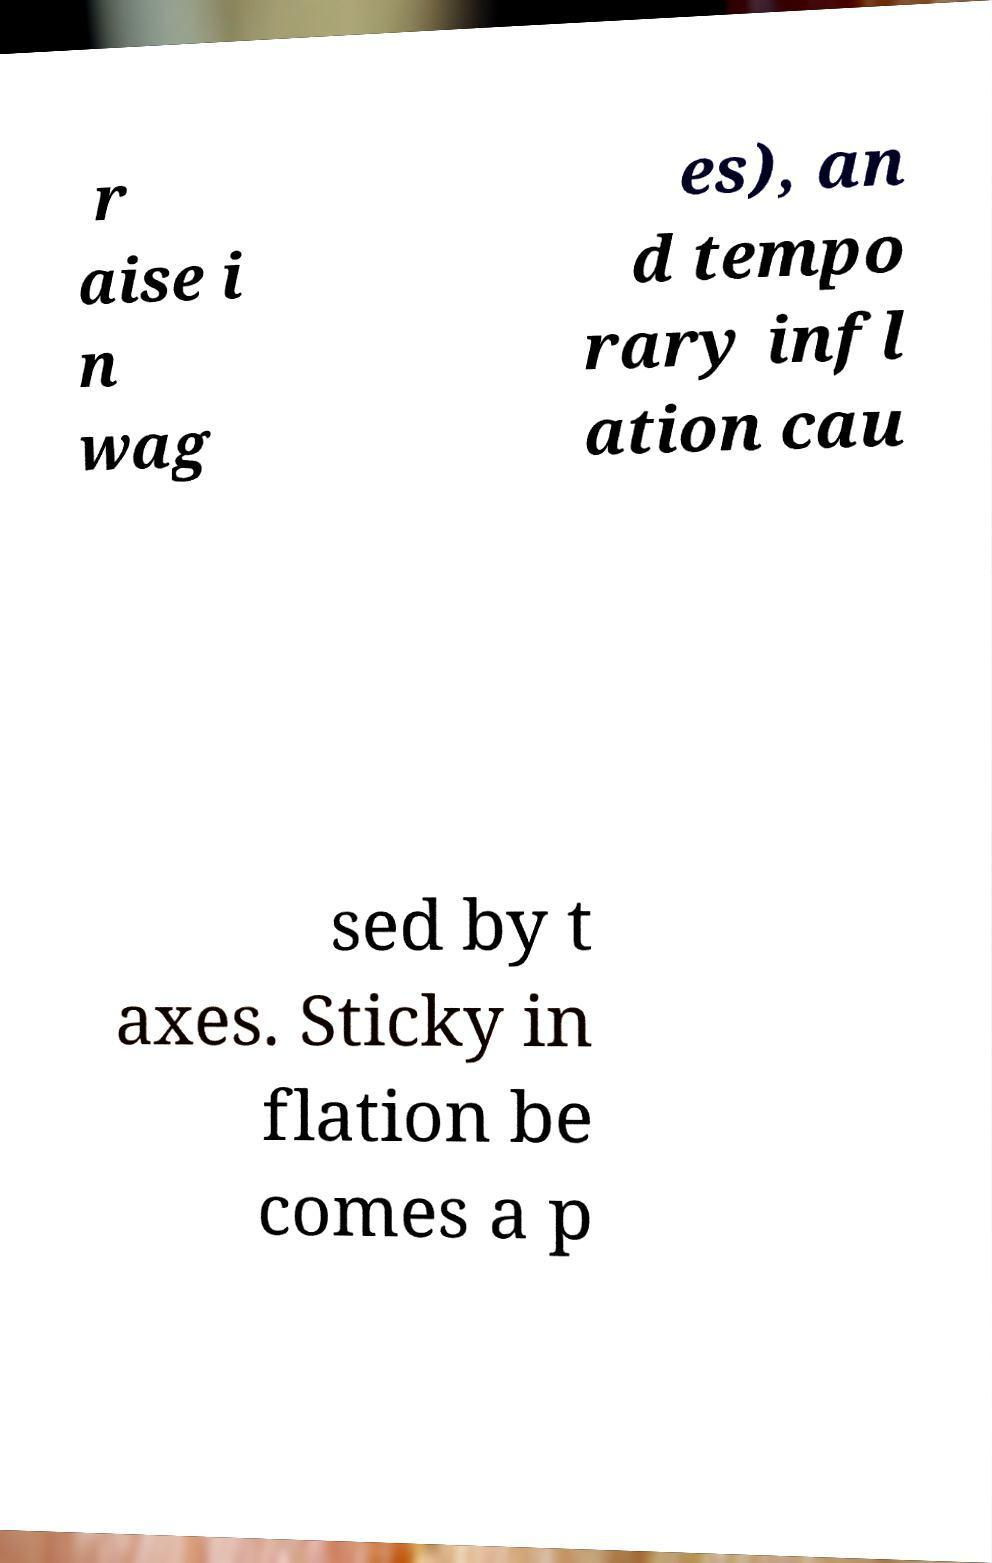There's text embedded in this image that I need extracted. Can you transcribe it verbatim? r aise i n wag es), an d tempo rary infl ation cau sed by t axes. Sticky in flation be comes a p 